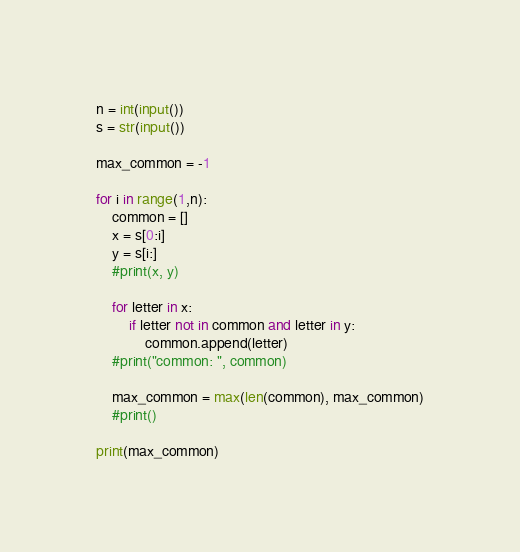Convert code to text. <code><loc_0><loc_0><loc_500><loc_500><_Python_>n = int(input())
s = str(input())

max_common = -1

for i in range(1,n):
    common = []
    x = s[0:i]
    y = s[i:]
    #print(x, y)
    
    for letter in x:
        if letter not in common and letter in y:
            common.append(letter)
    #print("common: ", common)
    
    max_common = max(len(common), max_common)
    #print()
    
print(max_common)</code> 